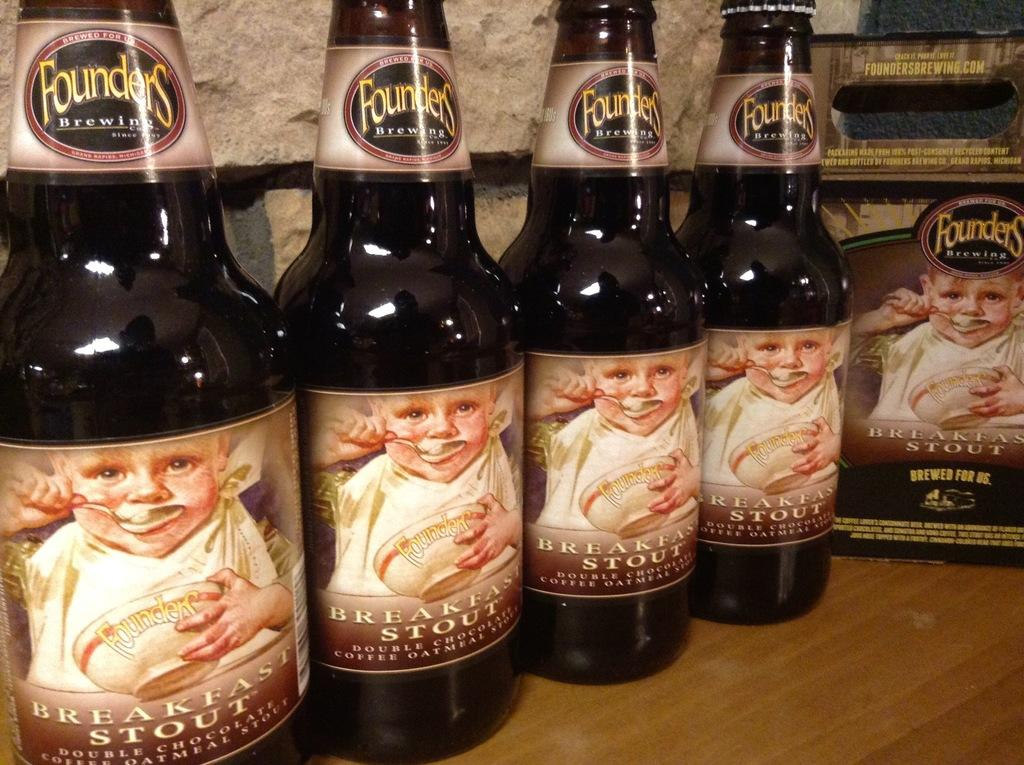Provide a one-sentence caption for the provided image. Several bottles of Founders beer called Breakfast Stout. 